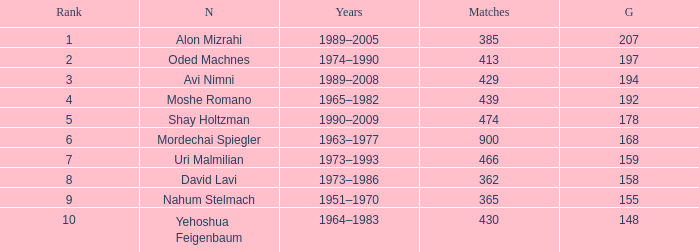Could you parse the entire table as a dict? {'header': ['Rank', 'N', 'Years', 'Matches', 'G'], 'rows': [['1', 'Alon Mizrahi', '1989–2005', '385', '207'], ['2', 'Oded Machnes', '1974–1990', '413', '197'], ['3', 'Avi Nimni', '1989–2008', '429', '194'], ['4', 'Moshe Romano', '1965–1982', '439', '192'], ['5', 'Shay Holtzman', '1990–2009', '474', '178'], ['6', 'Mordechai Spiegler', '1963–1977', '900', '168'], ['7', 'Uri Malmilian', '1973–1993', '466', '159'], ['8', 'David Lavi', '1973–1986', '362', '158'], ['9', 'Nahum Stelmach', '1951–1970', '365', '155'], ['10', 'Yehoshua Feigenbaum', '1964–1983', '430', '148']]} What is the Rank of the player with 362 Matches? 8.0. 